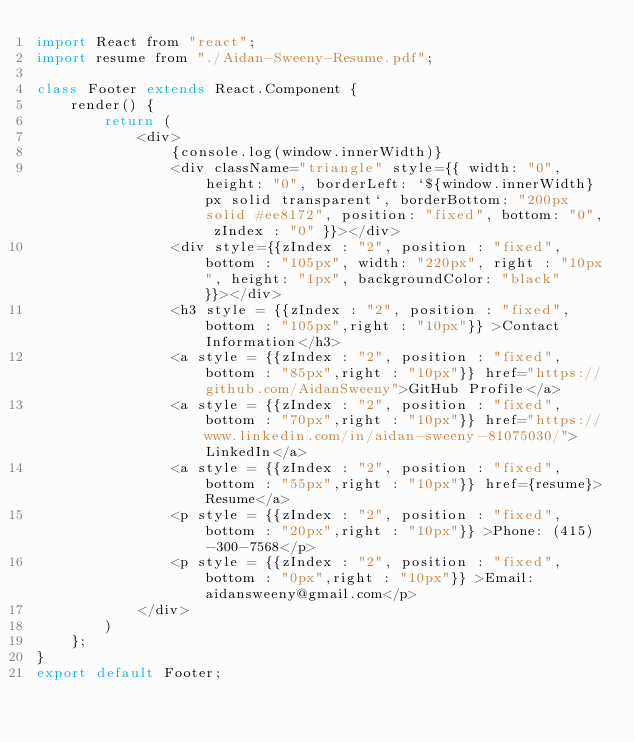Convert code to text. <code><loc_0><loc_0><loc_500><loc_500><_JavaScript_>import React from "react";
import resume from "./Aidan-Sweeny-Resume.pdf";

class Footer extends React.Component {
    render() {
        return (
            <div>
                {console.log(window.innerWidth)}
                <div className="triangle" style={{ width: "0", height: "0", borderLeft: `${window.innerWidth}px solid transparent`, borderBottom: "200px solid #ee8172", position: "fixed", bottom: "0", zIndex : "0" }}></div>
                <div style={{zIndex : "2", position : "fixed", bottom : "105px", width: "220px", right : "10px", height: "1px", backgroundColor: "black" }}></div>
                <h3 style = {{zIndex : "2", position : "fixed", bottom : "105px",right : "10px"}} >Contact Information</h3>
                <a style = {{zIndex : "2", position : "fixed", bottom : "85px",right : "10px"}} href="https://github.com/AidanSweeny">GitHub Profile</a>
                <a style = {{zIndex : "2", position : "fixed", bottom : "70px",right : "10px"}} href="https://www.linkedin.com/in/aidan-sweeny-81075030/">LinkedIn</a>
                <a style = {{zIndex : "2", position : "fixed", bottom : "55px",right : "10px"}} href={resume}>Resume</a>
                <p style = {{zIndex : "2", position : "fixed", bottom : "20px",right : "10px"}} >Phone: (415)-300-7568</p>
                <p style = {{zIndex : "2", position : "fixed", bottom : "0px",right : "10px"}} >Email: aidansweeny@gmail.com</p>
            </div>
        )
    };
}
export default Footer;</code> 